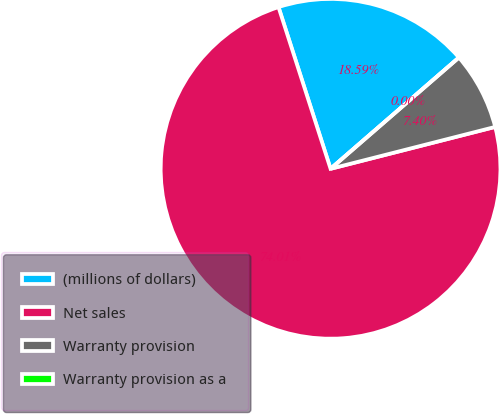Convert chart to OTSL. <chart><loc_0><loc_0><loc_500><loc_500><pie_chart><fcel>(millions of dollars)<fcel>Net sales<fcel>Warranty provision<fcel>Warranty provision as a<nl><fcel>18.59%<fcel>74.01%<fcel>7.4%<fcel>0.0%<nl></chart> 